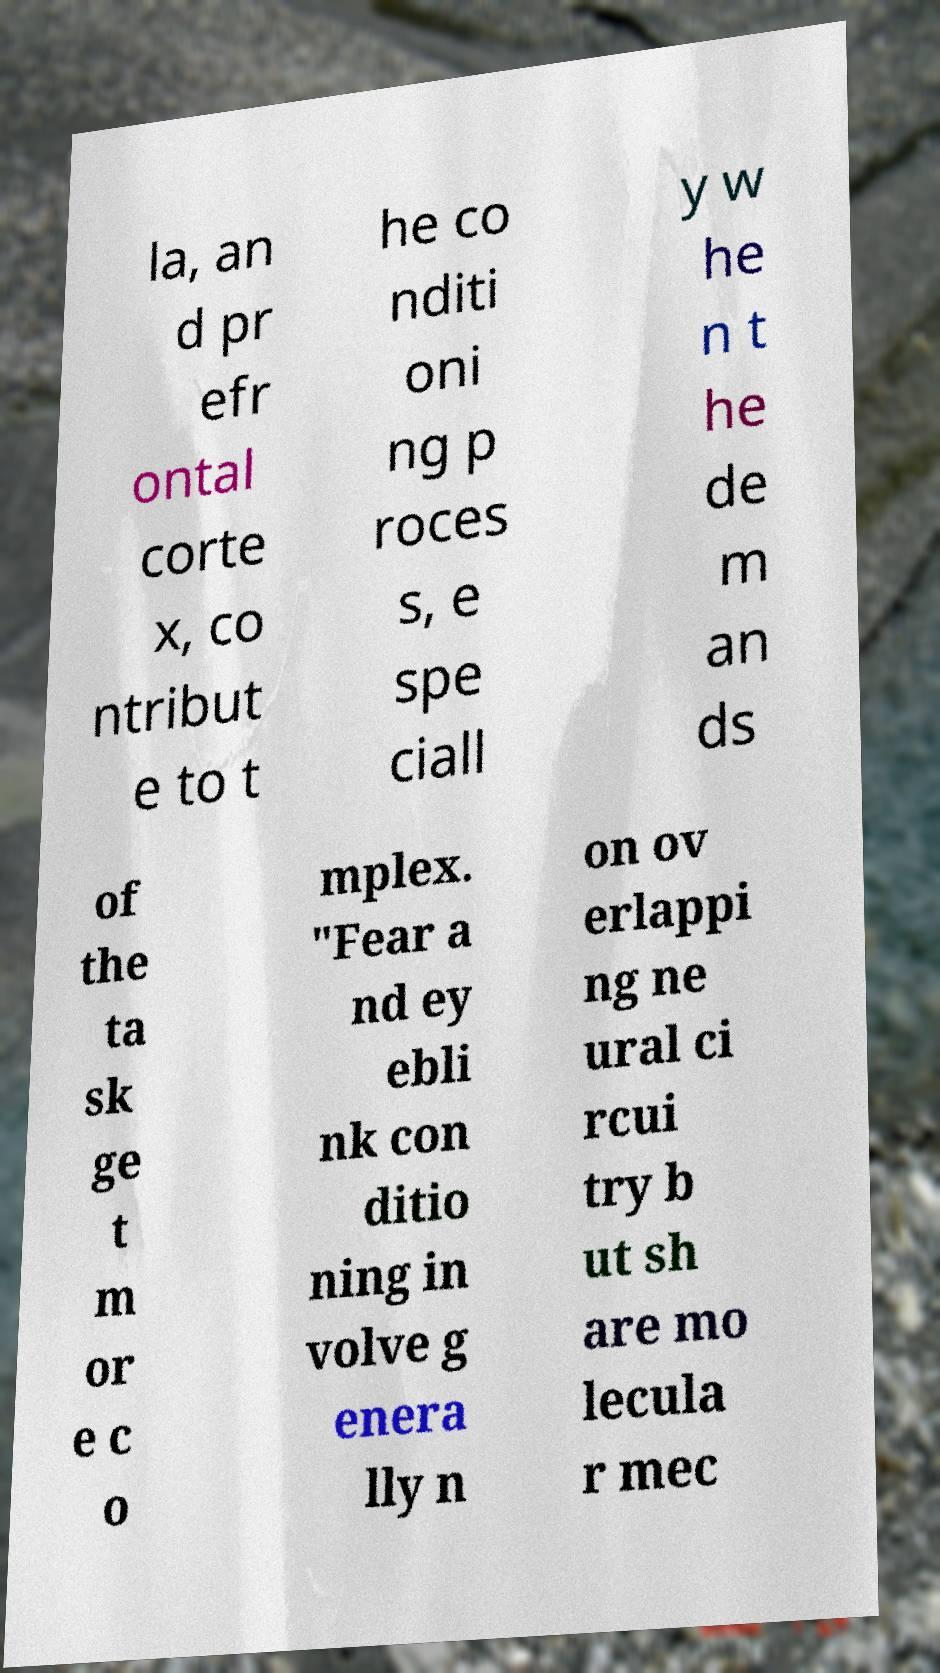There's text embedded in this image that I need extracted. Can you transcribe it verbatim? la, an d pr efr ontal corte x, co ntribut e to t he co nditi oni ng p roces s, e spe ciall y w he n t he de m an ds of the ta sk ge t m or e c o mplex. "Fear a nd ey ebli nk con ditio ning in volve g enera lly n on ov erlappi ng ne ural ci rcui try b ut sh are mo lecula r mec 